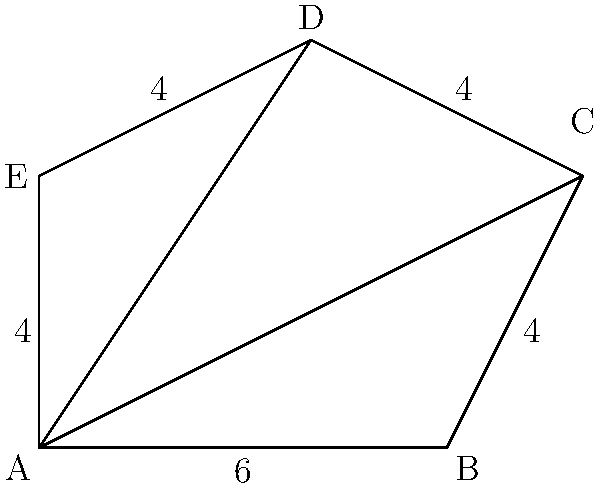In the irregular pentagon ABCDE shown above, all side lengths are given except for AB, which is 6 units. Diagonal AC divides the pentagon into a triangle and a quadrilateral. If $\angle CAB = 30°$ and $\angle ACD = 45°$, calculate the area of the entire pentagon. Let's approach this step-by-step:

1) First, let's divide the pentagon into two parts: triangle ABC and quadrilateral ACDE.

2) For triangle ABC:
   - We know AB = 6 and $\angle CAB = 30°$
   - We can find AC using the sine rule:
     $\frac{AC}{\sin 90°} = \frac{6}{\sin 30°}$
   - $AC = 6 \cdot \frac{\sin 90°}{\sin 30°} = 6 \cdot 2 = 12$

3) Now we can find the area of triangle ABC:
   $Area_{ABC} = \frac{1}{2} \cdot 6 \cdot 12 \cdot \sin 30° = 18$ sq units

4) For quadrilateral ACDE:
   - We know AC = 12 and $\angle ACD = 45°$
   - We can divide this into two triangles: ACD and ACE

5) For triangle ACD:
   - We know AC = 12, CD = 4, and $\angle ACD = 45°$
   - Area can be calculated as: $\frac{1}{2} \cdot 12 \cdot 4 \cdot \sin 45° = 12\sqrt{2}$ sq units

6) For triangle ACE:
   - We know AC = 12 and AE = 4
   - We can find $\angle CAE$ using the cosine rule:
     $\cos \angle CAE = \frac{12^2 + 4^2 - 4^2}{2 \cdot 12 \cdot 4} = \frac{11}{12}$
   - $\angle CAE = \arccos(\frac{11}{12}) \approx 23.07°$
   - Area of ACE = $\frac{1}{2} \cdot 12 \cdot 4 \cdot \sin 23.07° \approx 9.33$ sq units

7) Total area of the pentagon:
   $Area_{total} = 18 + 12\sqrt{2} + 9.33 \approx 44.29$ sq units
Answer: $44.29$ square units 